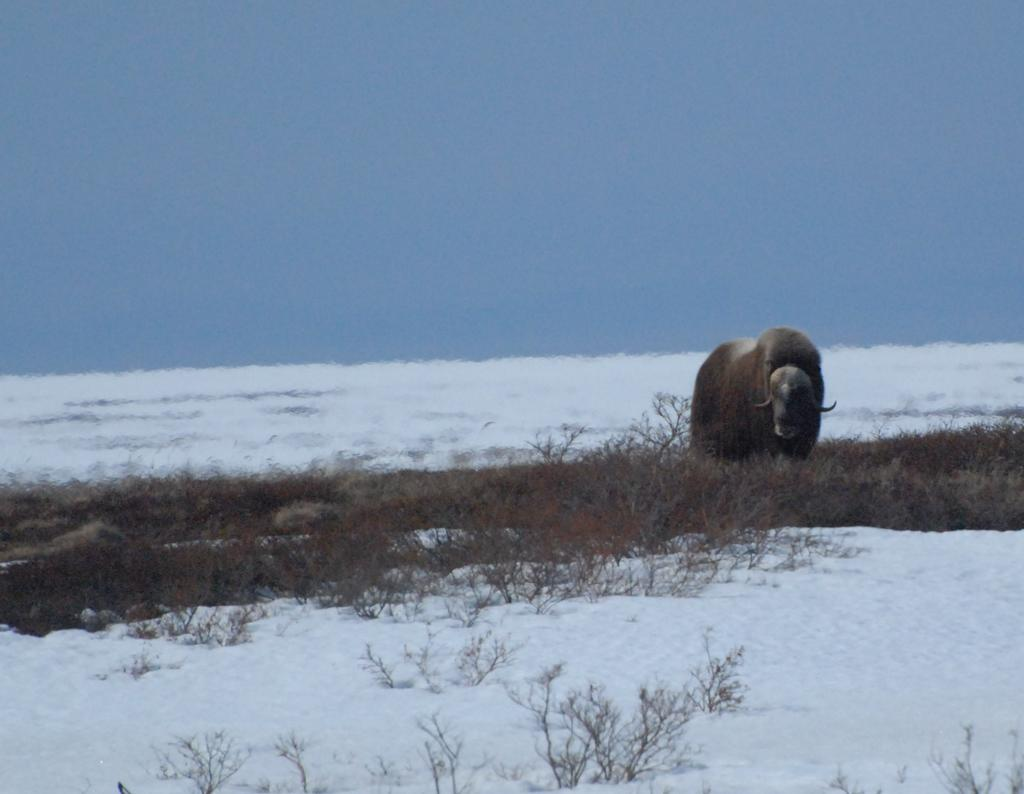What type of animal is in the image? The type of animal cannot be determined from the provided facts. What is the ground made of in the image? The ground is made of snow and grass in the image. What is visible in the background of the image? The sky is visible in the background of the image. What is the purpose of the volcano in the image? There is no volcano present in the image. How many clouds can be seen in the image? The number of clouds cannot be determined from the provided facts, as only the sky is mentioned, not specific clouds. 